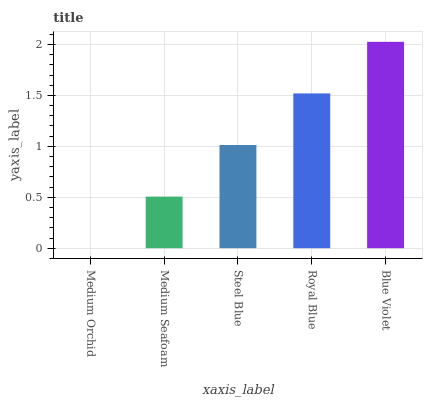Is Medium Orchid the minimum?
Answer yes or no. Yes. Is Blue Violet the maximum?
Answer yes or no. Yes. Is Medium Seafoam the minimum?
Answer yes or no. No. Is Medium Seafoam the maximum?
Answer yes or no. No. Is Medium Seafoam greater than Medium Orchid?
Answer yes or no. Yes. Is Medium Orchid less than Medium Seafoam?
Answer yes or no. Yes. Is Medium Orchid greater than Medium Seafoam?
Answer yes or no. No. Is Medium Seafoam less than Medium Orchid?
Answer yes or no. No. Is Steel Blue the high median?
Answer yes or no. Yes. Is Steel Blue the low median?
Answer yes or no. Yes. Is Royal Blue the high median?
Answer yes or no. No. Is Royal Blue the low median?
Answer yes or no. No. 